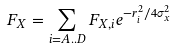<formula> <loc_0><loc_0><loc_500><loc_500>F _ { X } = \sum _ { i = A . . D } F _ { X , i } e ^ { - r _ { i } ^ { 2 } / 4 \sigma _ { x } ^ { 2 } }</formula> 